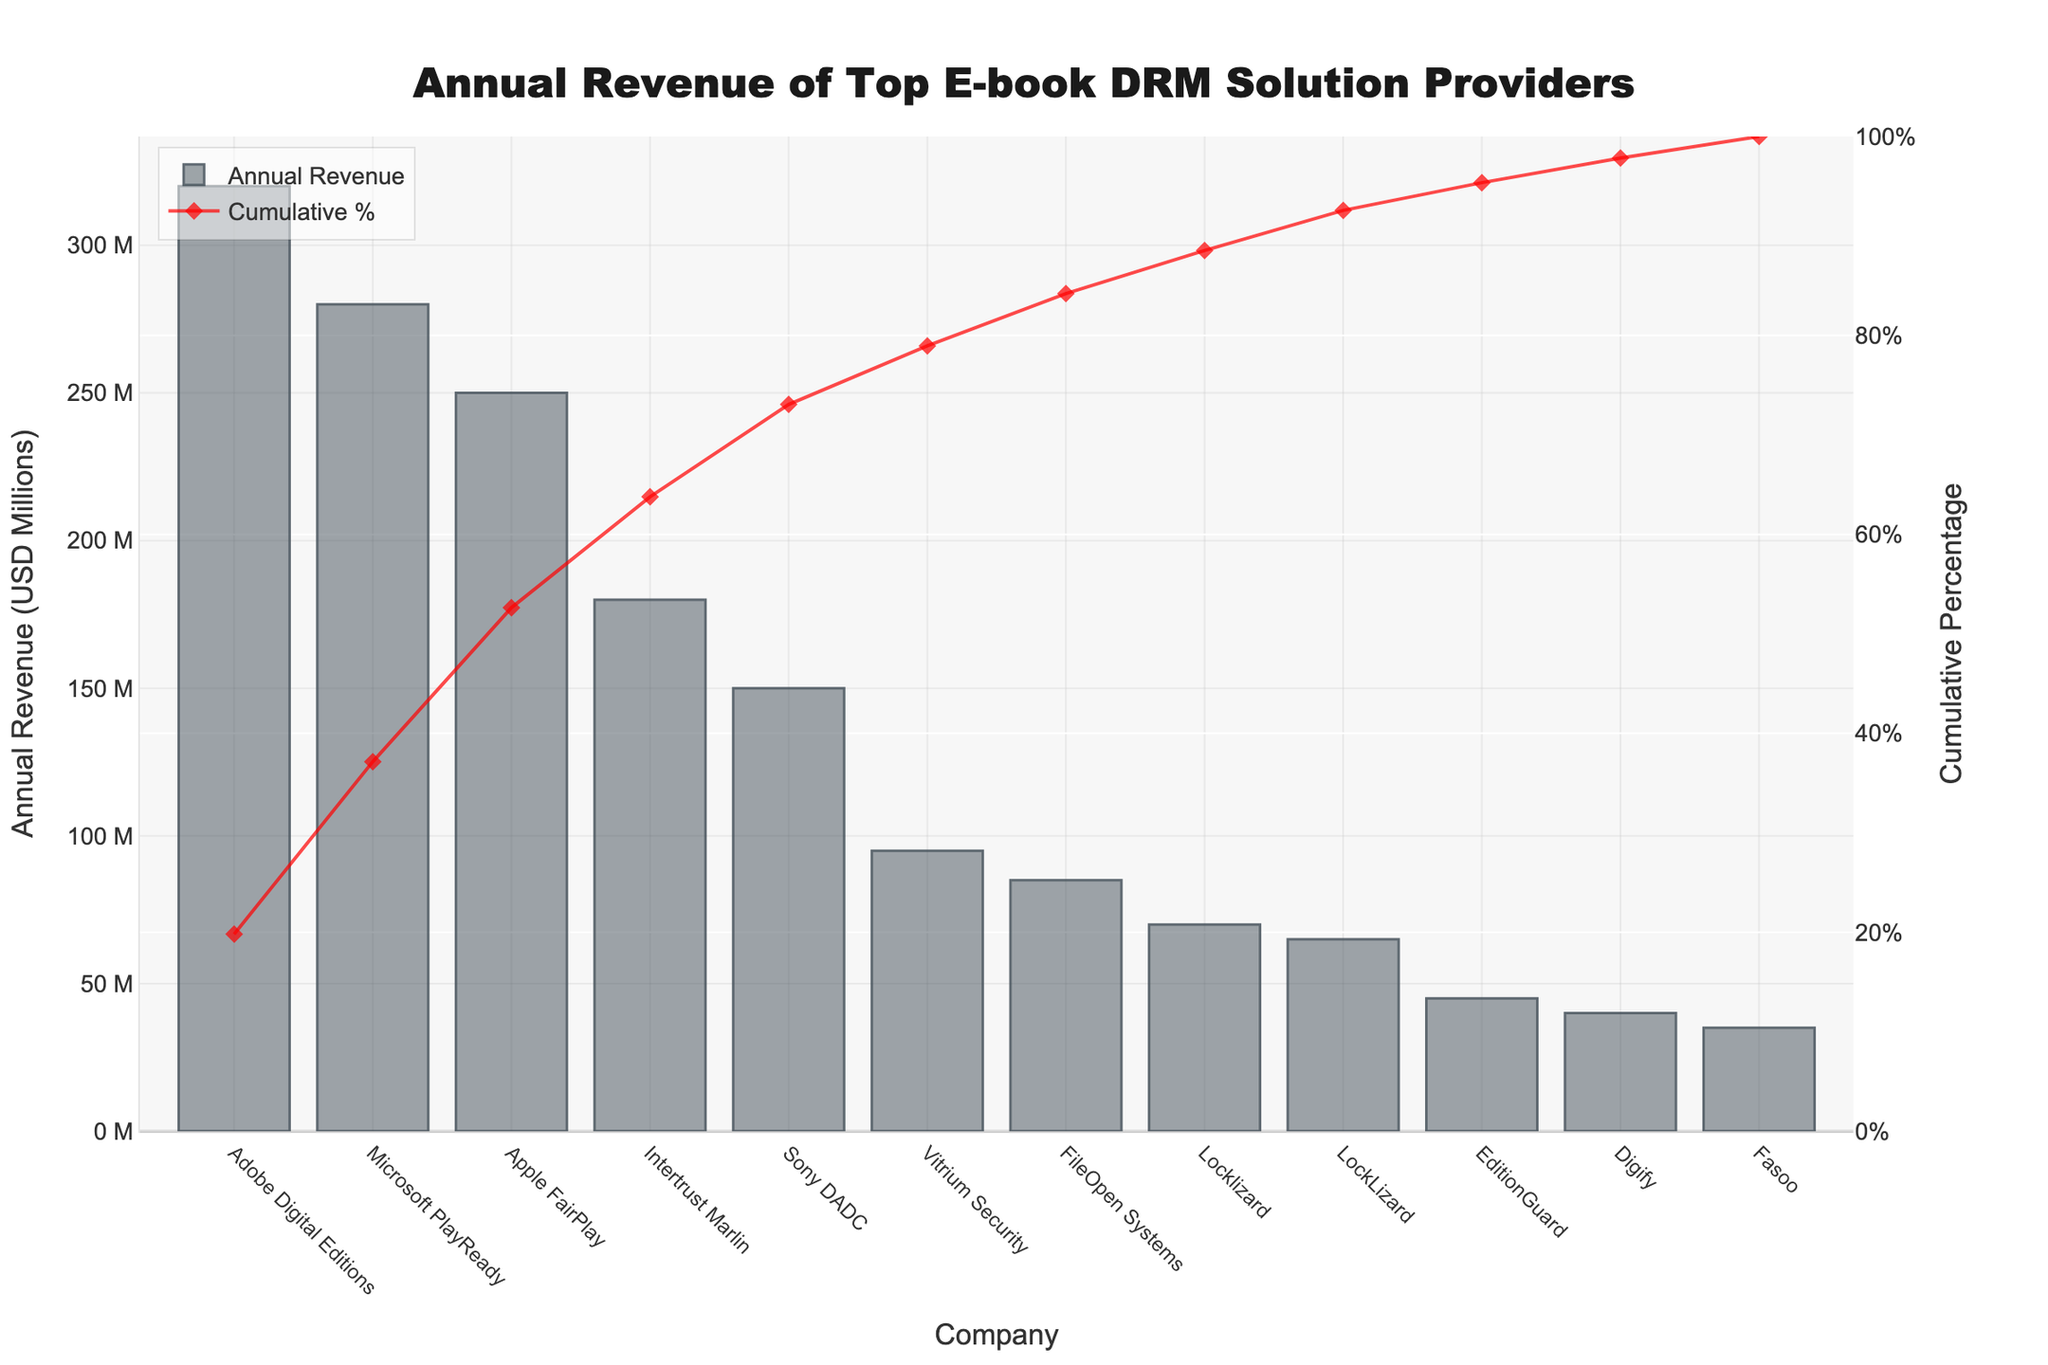Which company has the highest annual revenue? The bar chart shows Adobe Digital Editions has the tallest bar, indicating it has the highest annual revenue among the e-book DRM solution providers.
Answer: Adobe Digital Editions What is the combined annual revenue of Apple FairPlay and Intertrust Marlin? From the chart, Apple FairPlay and Intertrust Marlin have annual revenues of 250 and 180 million USD, respectively. The combined revenue is 250 + 180 = 430 million USD.
Answer: 430 million USD How many companies have annual revenues greater than 100 million USD? Observing the bars, Adobe Digital Editions, Microsoft PlayReady, Apple FairPlay, and Intertrust Marlin have revenues greater than 100 million USD. These are 4 companies in total.
Answer: 4 Among the companies with revenues under 100 million USD, which has the highest revenue? Looking at the shorter bars under 100 million USD, Vitrium Security stands out with 95 million USD in annual revenue.
Answer: Vitrium Security What is the cumulative percentage of the top two companies? The cumulative percentage for the top two companies, Adobe Digital Editions and Microsoft PlayReady, can be read from the red line on the chart. The value near Apple FairPlay (the third company) should closely reflect this value, which is around 64%.
Answer: ~64% What is the revenue difference between Sony DADC and FileOpen Systems? Sony DADC has 150 million USD and FileOpen Systems has 85 million USD. The difference is 150 - 85 = 65 million USD.
Answer: 65 million USD What percentage of the total revenue does Adobe Digital Editions represent? Adobe Digital Editions has 320 million USD. Summing all the bar heights gives the total revenue: 320 + 280 + 250 + 180 + 150 + 95 + 85 + 70 + 65 + 45 + 40 + 35 = 1615 million USD. The percentage is (320 / 1615) * 100 ≈ 19.8%.
Answer: ~19.8% Which two companies have the smallest difference in their annual revenues and what is that difference? Looking at the consecutively positioned bars, Locklizard (70 million USD) and LockLizard (65 million USD) have the smallest revenue difference of 70 - 65 = 5 million USD.
Answer: Locklizard and LockLizard, 5 million USD What is the total revenue of the companies with annual revenue less than 50 million USD? Summing the bars under 50 million USD: EditionGuard (45) + Digify (40) + Fasoo (35) = 120 million USD.
Answer: 120 million USD 